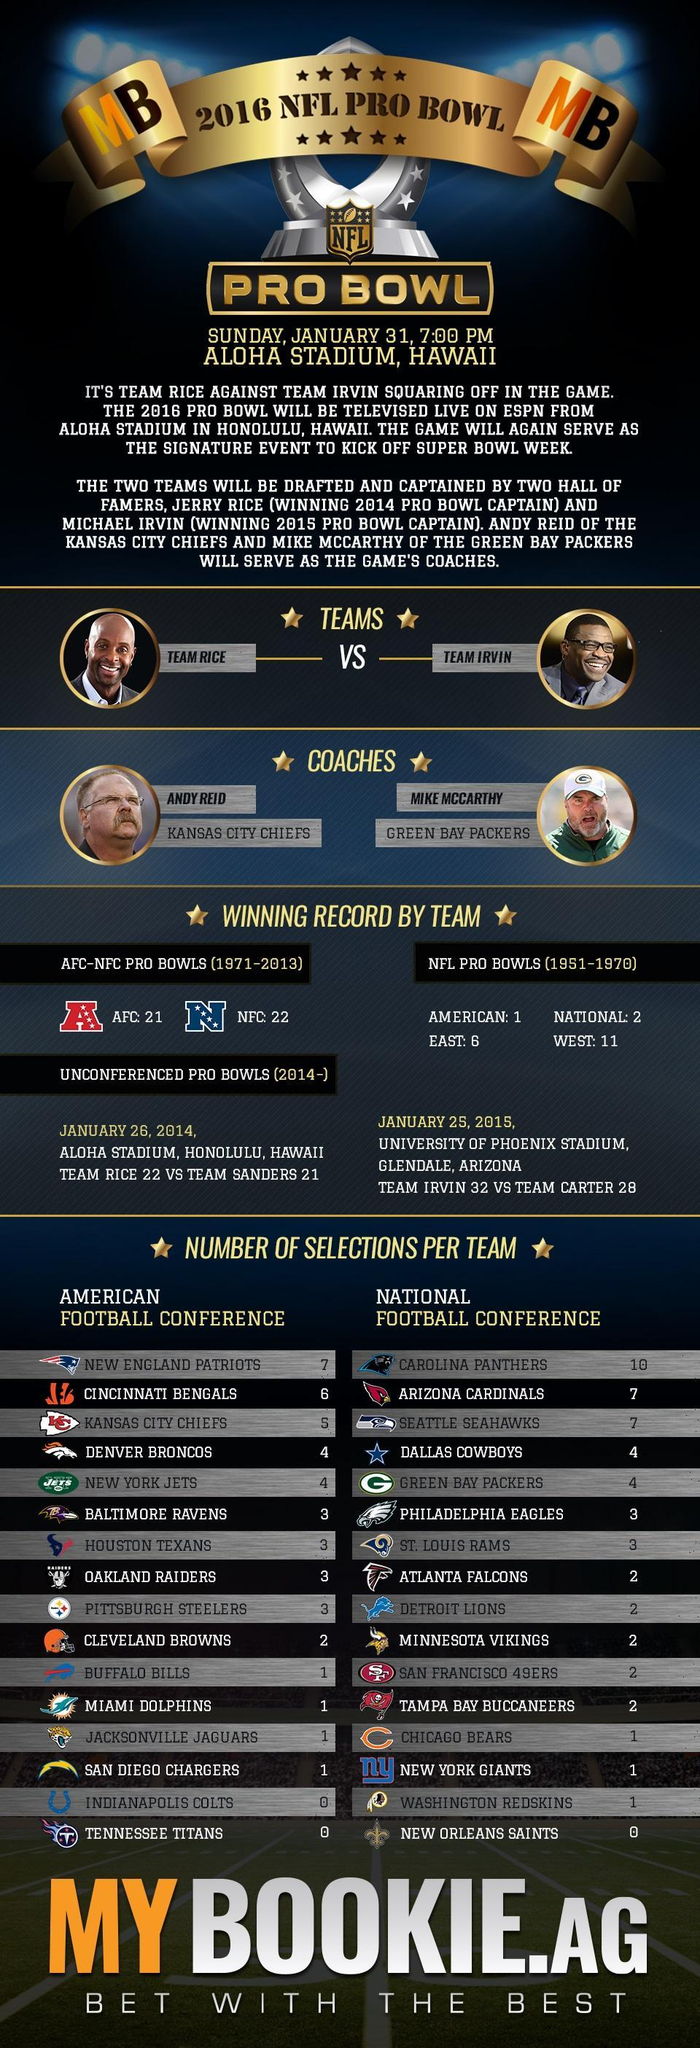Which NFL conference has more wins in the Pro Bowl during 1971-2013?
Answer the question with a short phrase. NFC What does AFC stands for? AMERICAN FOOTBALL CONFERENCE How many teams are in AFC? 16 How many games were won by the NFC in Pro Bowls during 1971-2013? 22 Who was 'Green Bay Packers' coach in 2016 NFL Pro Bowl? MIKE MCCARTHY 